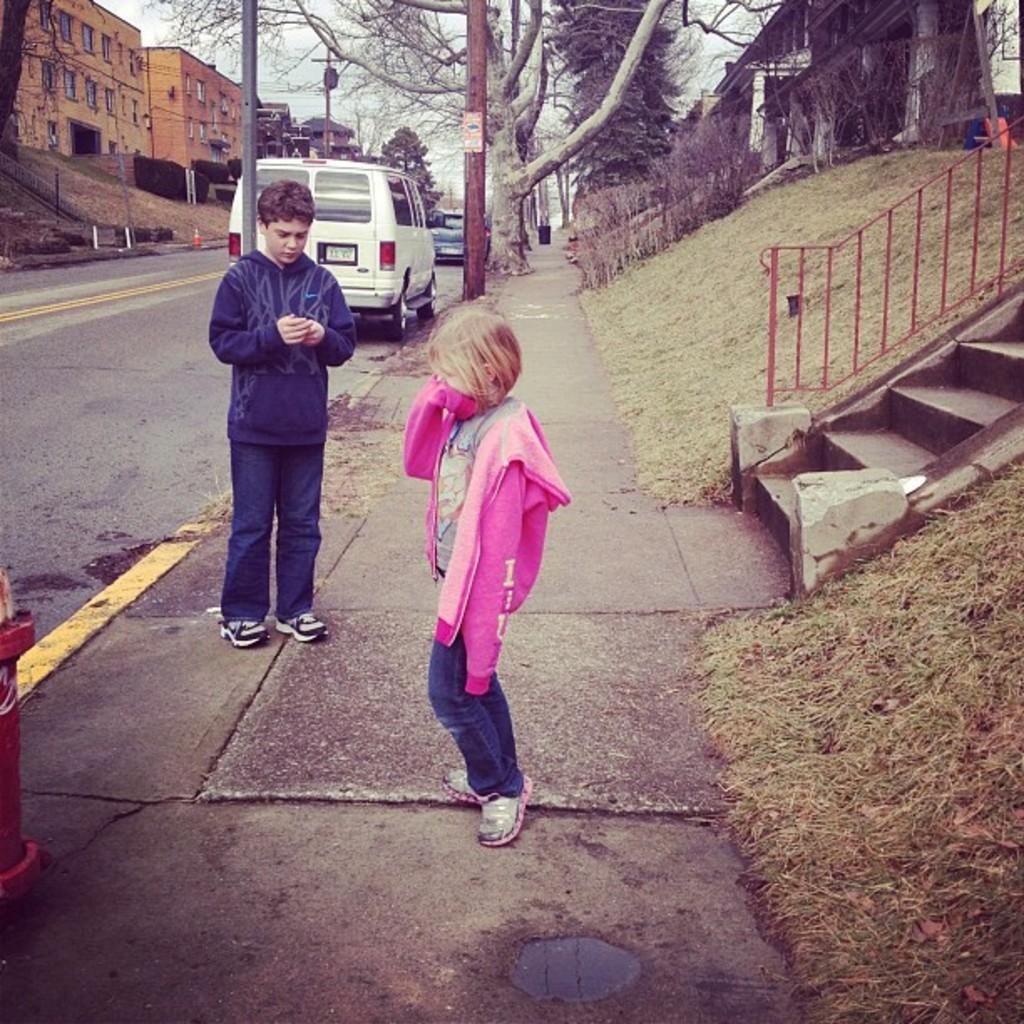How would you summarize this image in a sentence or two? In this picture we can see two persons standing on the walkway. Beside the person's there are stairs, railing and grass. In the background of the image we can see some vehicles parked on the road, trees, buildings and the sky. 